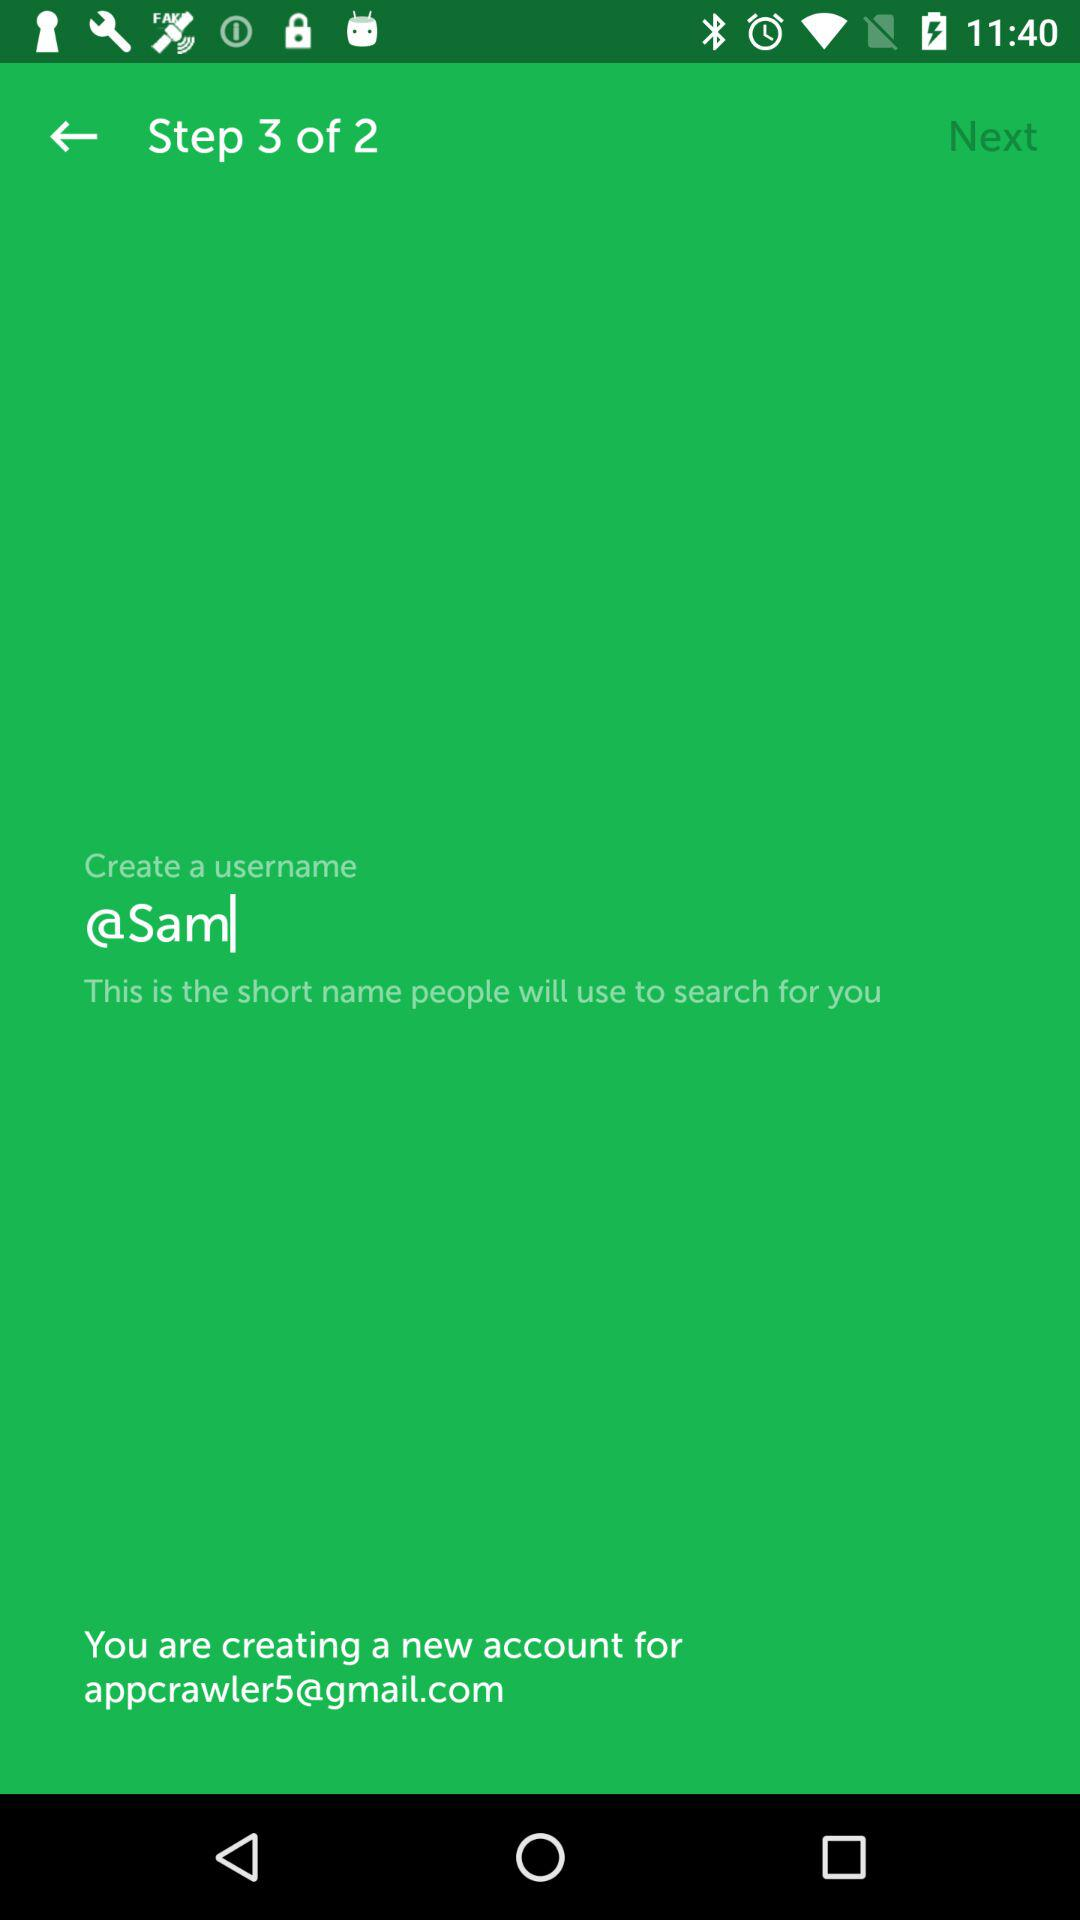At which step am I? You are at step 3. 